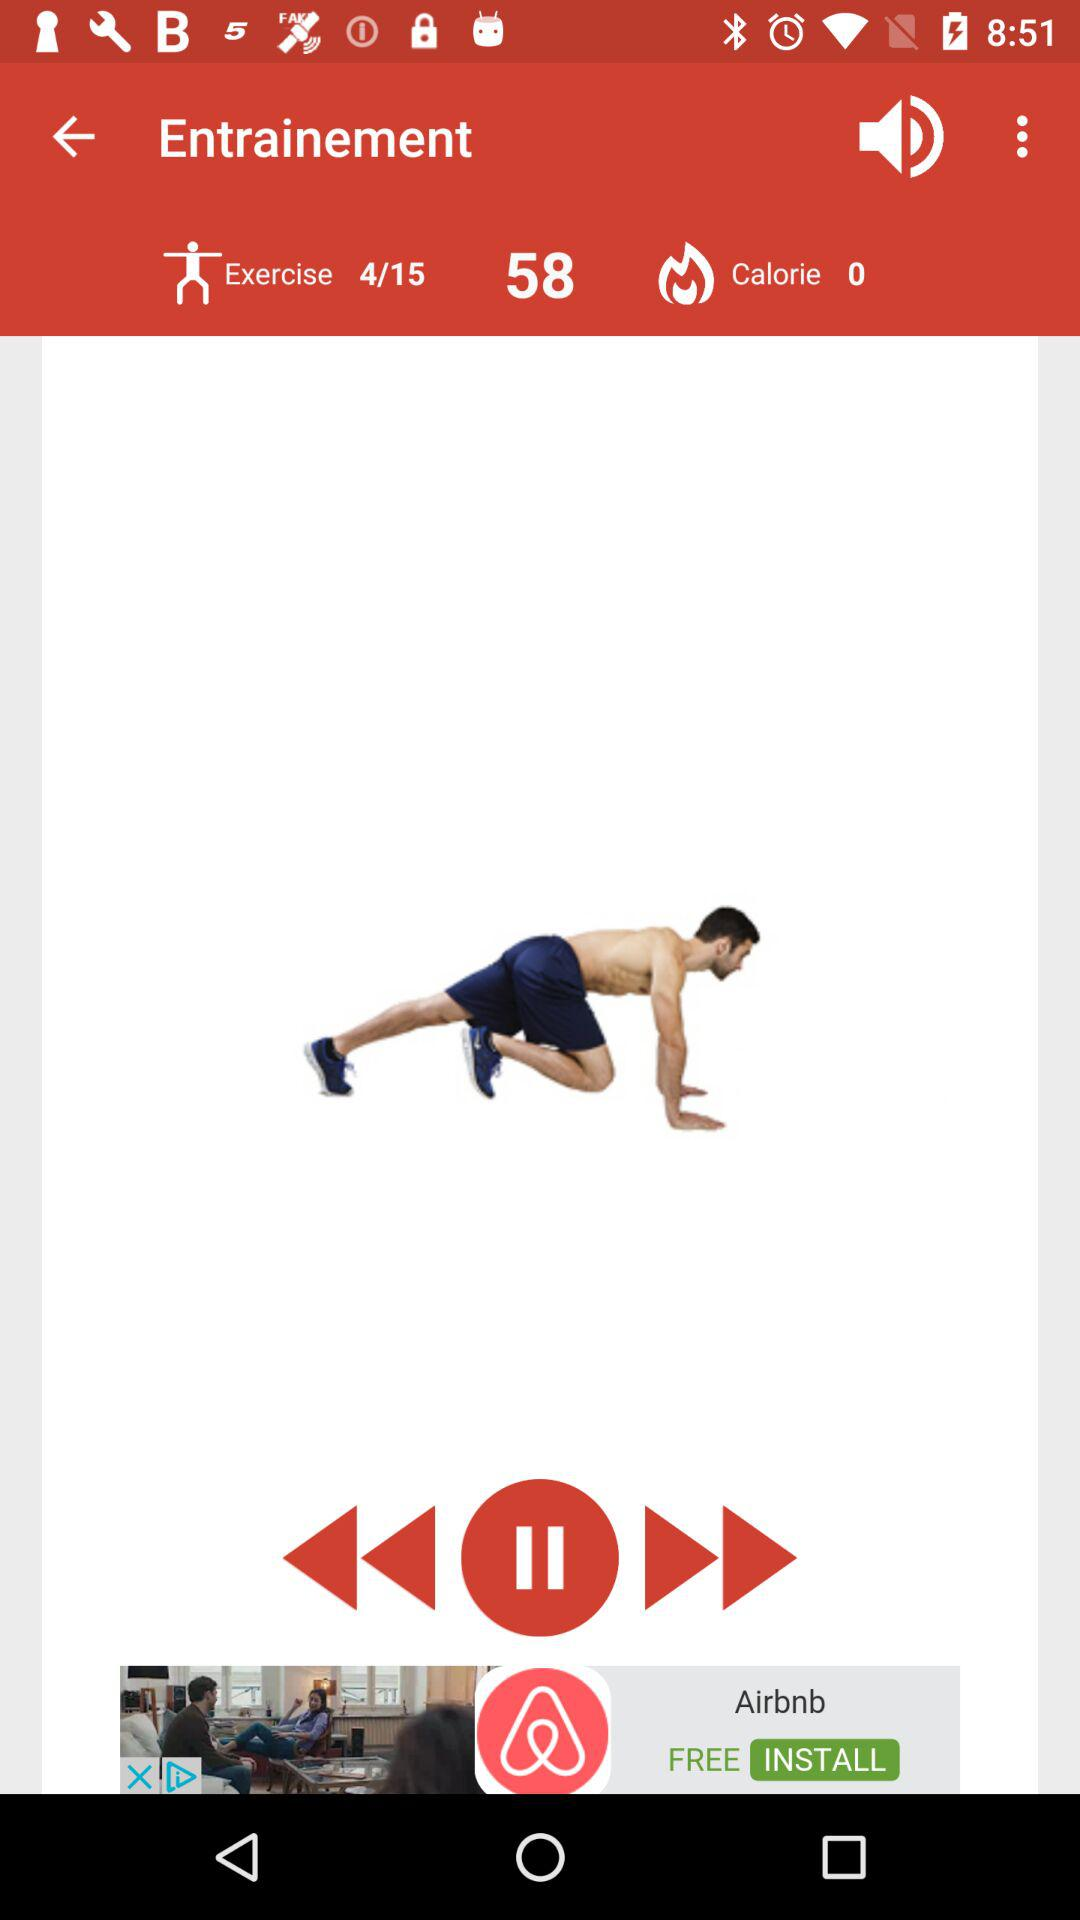At which exercise is the person? The person is on the 4th exercise. 